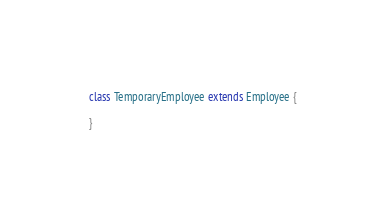<code> <loc_0><loc_0><loc_500><loc_500><_Scala_>
class TemporaryEmployee extends Employee {
  
}</code> 